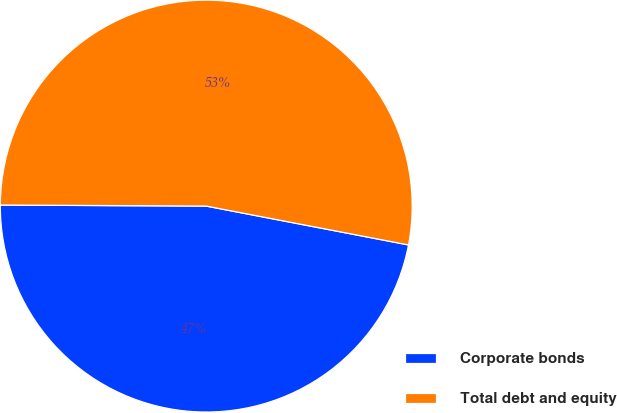Convert chart to OTSL. <chart><loc_0><loc_0><loc_500><loc_500><pie_chart><fcel>Corporate bonds<fcel>Total debt and equity<nl><fcel>47.06%<fcel>52.94%<nl></chart> 